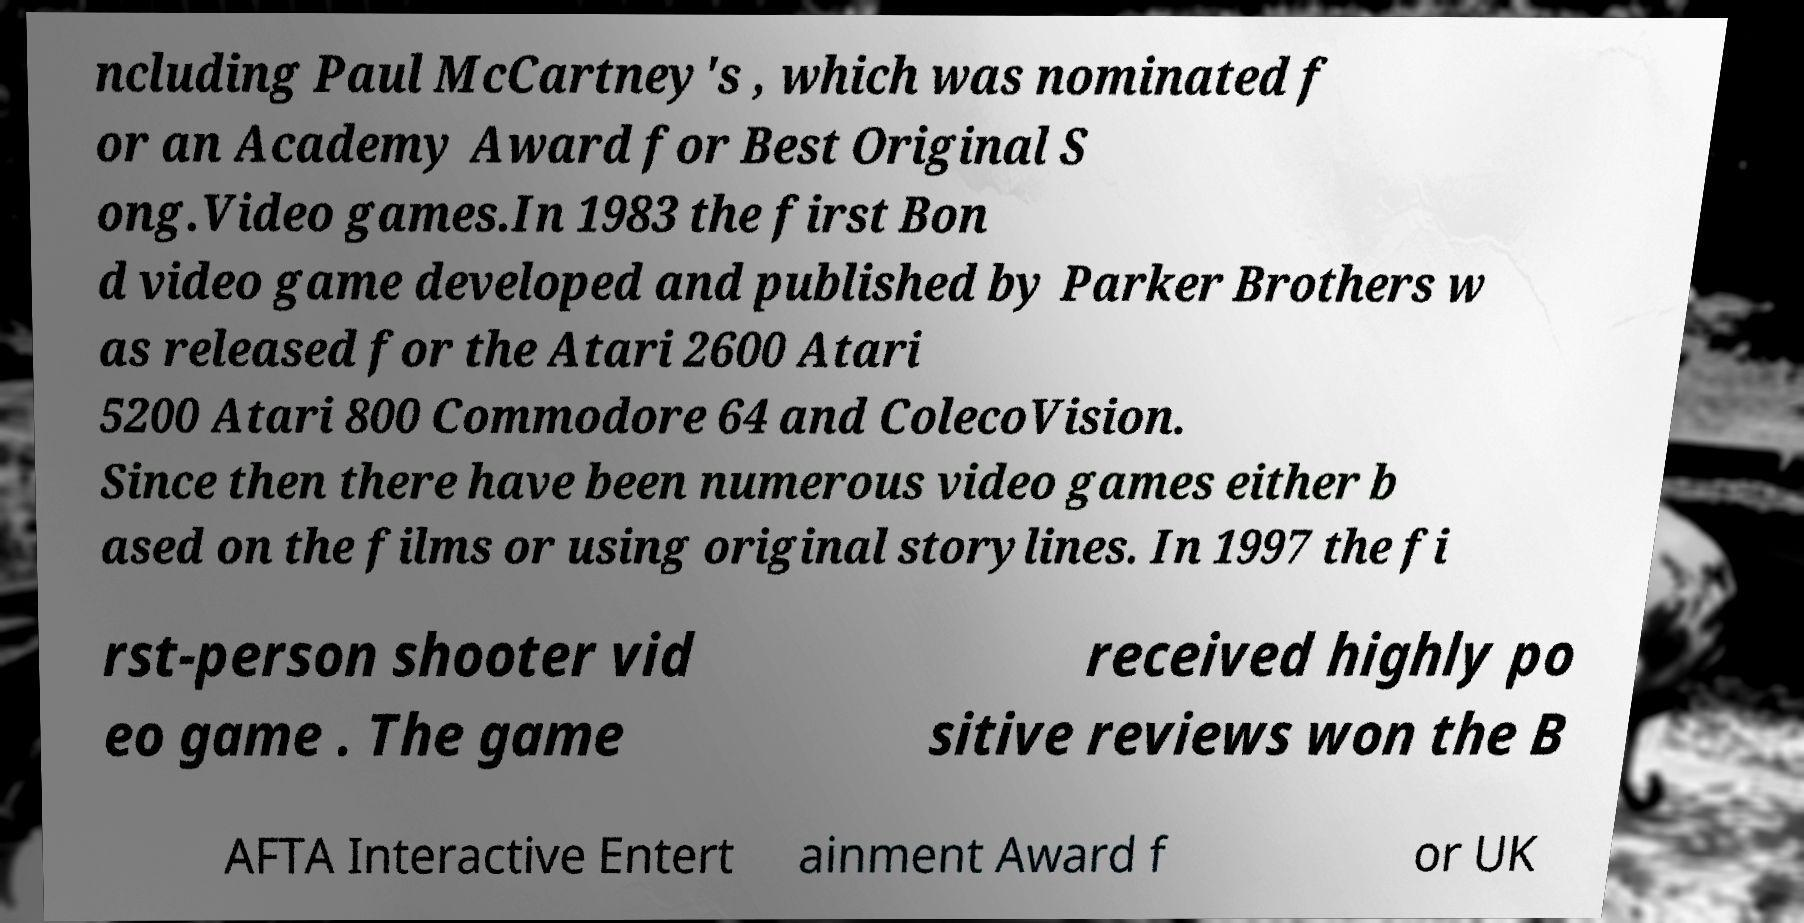Please identify and transcribe the text found in this image. ncluding Paul McCartney's , which was nominated f or an Academy Award for Best Original S ong.Video games.In 1983 the first Bon d video game developed and published by Parker Brothers w as released for the Atari 2600 Atari 5200 Atari 800 Commodore 64 and ColecoVision. Since then there have been numerous video games either b ased on the films or using original storylines. In 1997 the fi rst-person shooter vid eo game . The game received highly po sitive reviews won the B AFTA Interactive Entert ainment Award f or UK 